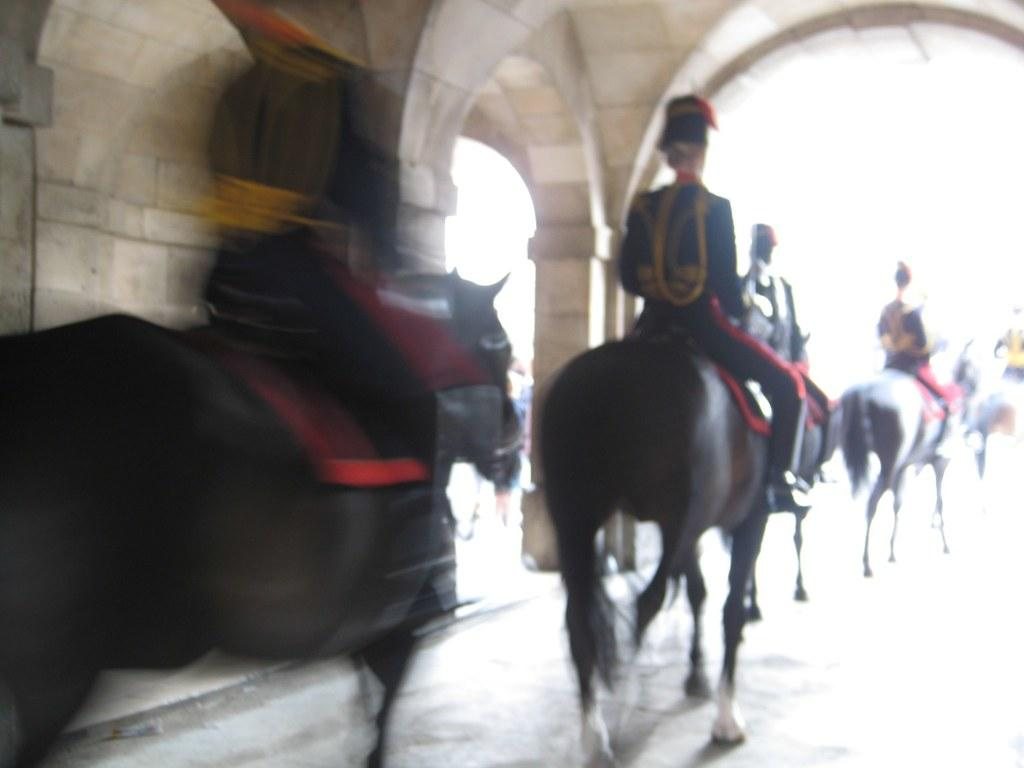What are the people in the image doing? The people in the image are riding horses. What architectural features can be seen on the left side of the image? There are pillars and a wall on the left side of the image. What color is the background of the image? The background of the image is white. What type of current can be seen flowing through the vessel in the image? There is no vessel or current present in the image; it features people riding horses with a white background and architectural features on the left side. 